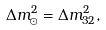<formula> <loc_0><loc_0><loc_500><loc_500>\Delta m ^ { 2 } _ { \odot } = \Delta m ^ { 2 } _ { 3 2 } ,</formula> 